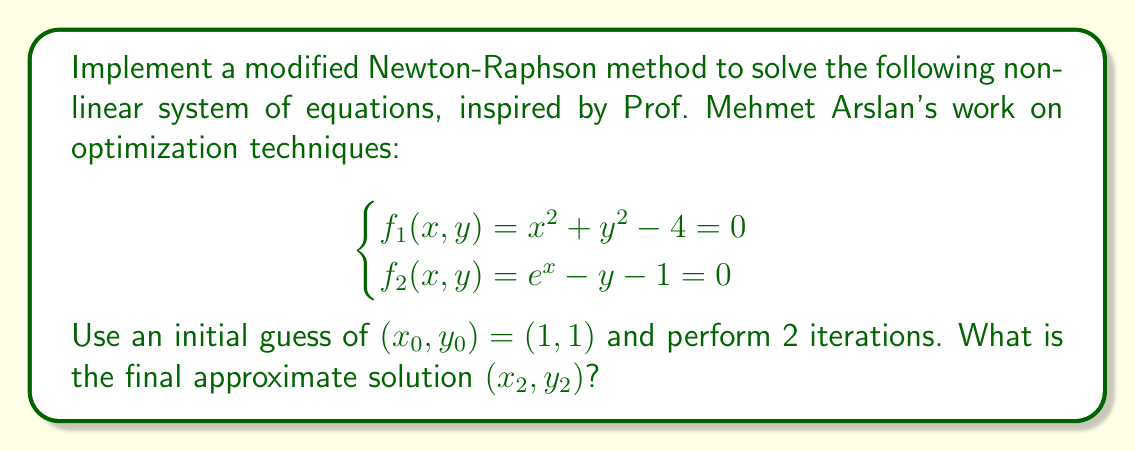Show me your answer to this math problem. Let's implement the modified Newton-Raphson method for this system:

1) First, we need to calculate the Jacobian matrix:

   $$J(x,y) = \begin{bmatrix}
   \frac{\partial f_1}{\partial x} & \frac{\partial f_1}{\partial y} \\
   \frac{\partial f_2}{\partial x} & \frac{\partial f_2}{\partial y}
   \end{bmatrix} = \begin{bmatrix}
   2x & 2y \\
   e^x & -1
   \end{bmatrix}$$

2) The modified Newton-Raphson method uses the same Jacobian for multiple iterations. We'll calculate it at the initial point $(1, 1)$:

   $$J(1,1) = \begin{bmatrix}
   2 & 2 \\
   e & -1
   \end{bmatrix}$$

3) The iteration formula is:

   $$\begin{bmatrix} x_{k+1} \\ y_{k+1} \end{bmatrix} = \begin{bmatrix} x_k \\ y_k \end{bmatrix} - J(1,1)^{-1} \begin{bmatrix} f_1(x_k, y_k) \\ f_2(x_k, y_k) \end{bmatrix}$$

4) Calculate $J(1,1)^{-1}$:

   $$J(1,1)^{-1} = \frac{1}{2e+2} \begin{bmatrix}
   -1 & -2 \\
   -e & 2
   \end{bmatrix}$$

5) First iteration $(k=0)$:
   
   $$\begin{bmatrix} x_1 \\ y_1 \end{bmatrix} = \begin{bmatrix} 1 \\ 1 \end{bmatrix} - \frac{1}{2e+2} \begin{bmatrix}
   -1 & -2 \\
   -e & 2
   \end{bmatrix} \begin{bmatrix} 1^2 + 1^2 - 4 \\ e^1 - 1 - 1 \end{bmatrix}$$

   $$= \begin{bmatrix} 1 \\ 1 \end{bmatrix} - \frac{1}{2e+2} \begin{bmatrix}
   -1 & -2 \\
   -e & 2
   \end{bmatrix} \begin{bmatrix} -2 \\ e-2 \end{bmatrix}$$

   $$= \begin{bmatrix} 1 \\ 1 \end{bmatrix} + \frac{1}{2e+2} \begin{bmatrix} 2-2e \\ 2e-4 \end{bmatrix}$$

   $$= \begin{bmatrix} 1 + \frac{2-2e}{2e+2} \\ 1 + \frac{2e-4}{2e+2} \end{bmatrix} \approx \begin{bmatrix} 0.4892 \\ 1.4055 \end{bmatrix}$$

6) Second iteration $(k=1)$:

   $$\begin{bmatrix} x_2 \\ y_2 \end{bmatrix} = \begin{bmatrix} 0.4892 \\ 1.4055 \end{bmatrix} - \frac{1}{2e+2} \begin{bmatrix}
   -1 & -2 \\
   -e & 2
   \end{bmatrix} \begin{bmatrix} 0.4892^2 + 1.4055^2 - 4 \\ e^{0.4892} - 1.4055 - 1 \end{bmatrix}$$

   $$\approx \begin{bmatrix} 0.4892 \\ 1.4055 \end{bmatrix} - \frac{1}{2e+2} \begin{bmatrix}
   -1 & -2 \\
   -e & 2
   \end{bmatrix} \begin{bmatrix} -1.7863 \\ -0.7154 \end{bmatrix}$$

   $$\approx \begin{bmatrix} 0.4892 \\ 1.4055 \end{bmatrix} + \frac{1}{2e+2} \begin{bmatrix} 1.7863 - 1.4308 \\ 1.7863e + 1.4308 \end{bmatrix}$$

   $$\approx \begin{bmatrix} 0.5735 \\ 1.3506 \end{bmatrix}$$
Answer: $(x_2, y_2) \approx (0.5735, 1.3506)$ 